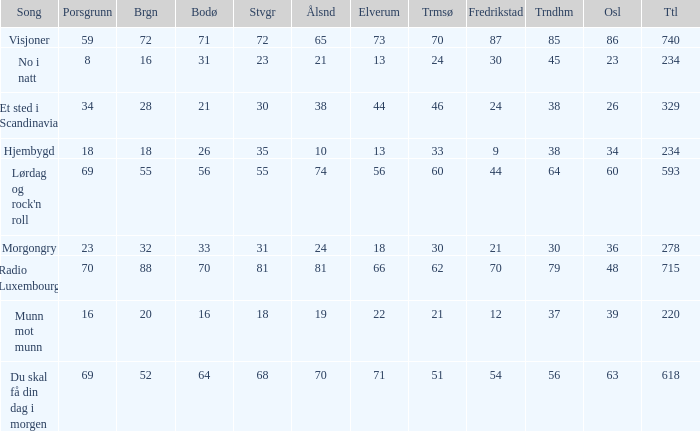How many elverum are tehre for et sted i scandinavia? 1.0. 